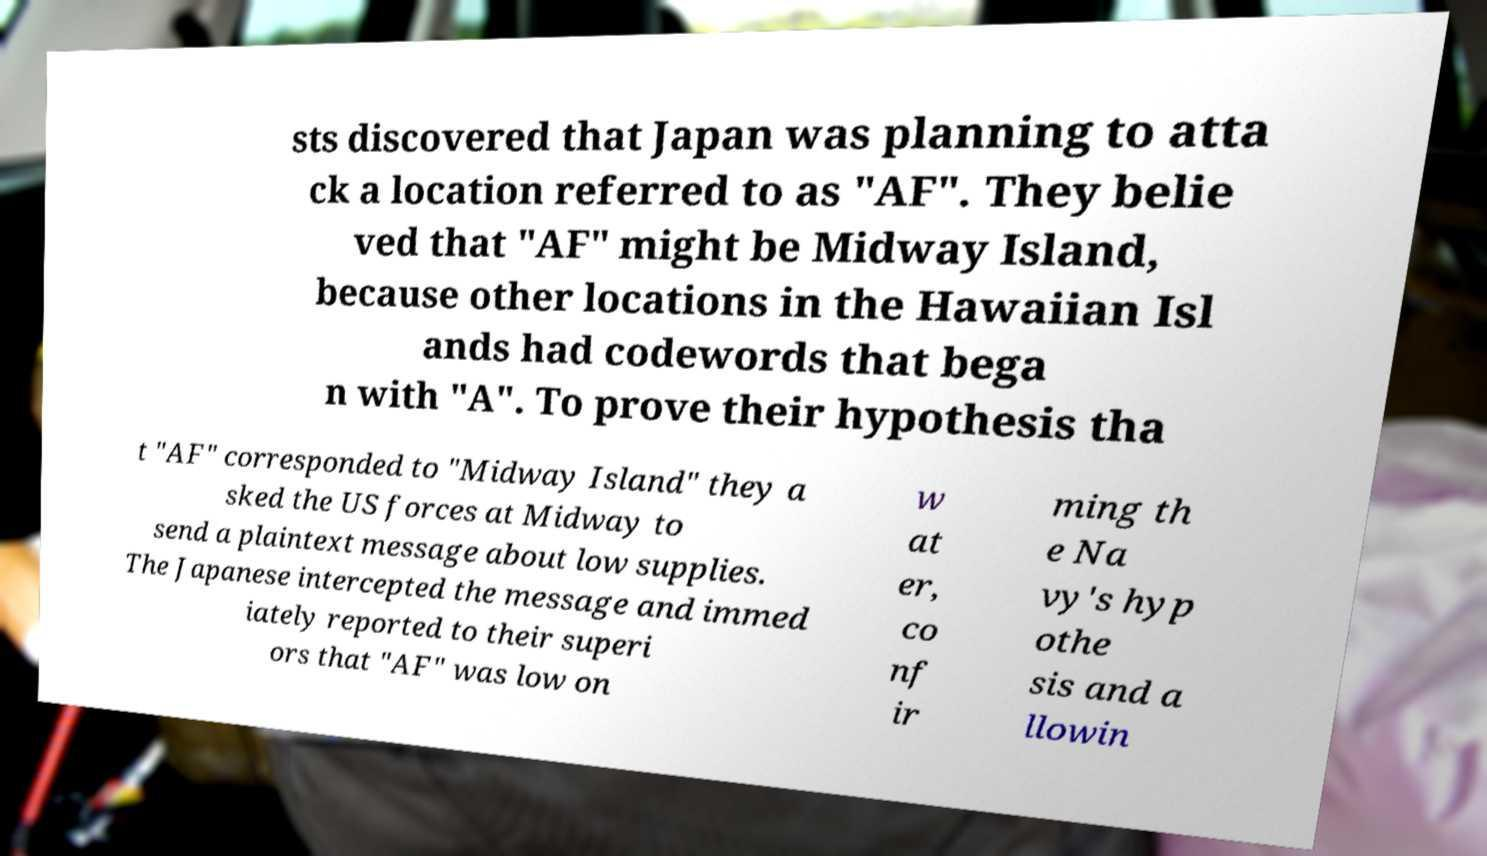Can you read and provide the text displayed in the image?This photo seems to have some interesting text. Can you extract and type it out for me? sts discovered that Japan was planning to atta ck a location referred to as "AF". They belie ved that "AF" might be Midway Island, because other locations in the Hawaiian Isl ands had codewords that bega n with "A". To prove their hypothesis tha t "AF" corresponded to "Midway Island" they a sked the US forces at Midway to send a plaintext message about low supplies. The Japanese intercepted the message and immed iately reported to their superi ors that "AF" was low on w at er, co nf ir ming th e Na vy's hyp othe sis and a llowin 